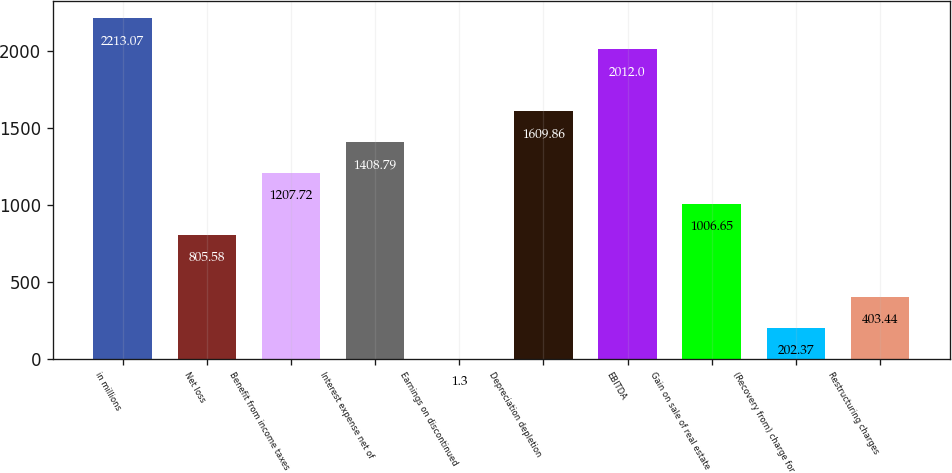<chart> <loc_0><loc_0><loc_500><loc_500><bar_chart><fcel>in millions<fcel>Net loss<fcel>Benefit from income taxes<fcel>Interest expense net of<fcel>Earnings on discontinued<fcel>Depreciation depletion<fcel>EBITDA<fcel>Gain on sale of real estate<fcel>(Recovery from) charge for<fcel>Restructuring charges<nl><fcel>2213.07<fcel>805.58<fcel>1207.72<fcel>1408.79<fcel>1.3<fcel>1609.86<fcel>2012<fcel>1006.65<fcel>202.37<fcel>403.44<nl></chart> 